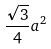<formula> <loc_0><loc_0><loc_500><loc_500>\frac { \sqrt { 3 } } { 4 } a ^ { 2 }</formula> 